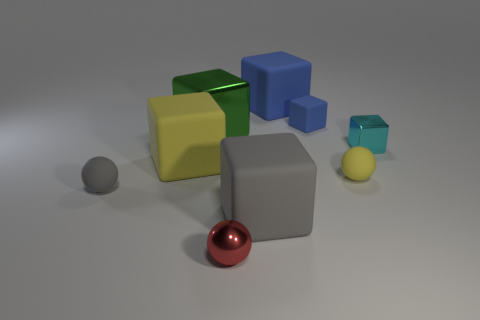Subtract all yellow cylinders. How many blue blocks are left? 2 Subtract all small gray rubber spheres. How many spheres are left? 2 Add 1 small gray matte things. How many objects exist? 10 Subtract all yellow cubes. How many cubes are left? 5 Subtract all green cubes. Subtract all cyan spheres. How many cubes are left? 5 Subtract all balls. How many objects are left? 6 Add 8 cyan metal blocks. How many cyan metal blocks are left? 9 Add 5 small shiny balls. How many small shiny balls exist? 6 Subtract 1 yellow spheres. How many objects are left? 8 Subtract all big cyan rubber cubes. Subtract all green cubes. How many objects are left? 8 